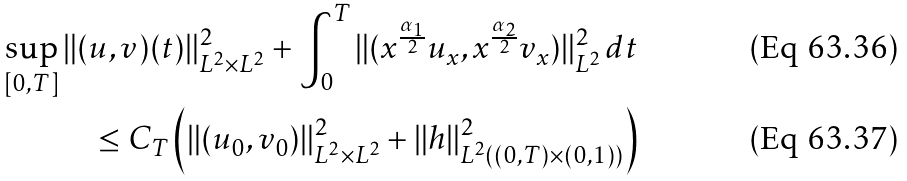Convert formula to latex. <formula><loc_0><loc_0><loc_500><loc_500>\sup _ { [ 0 , T ] } \| ( u , v ) ( t ) \| ^ { 2 } _ { L ^ { 2 } \times L ^ { 2 } } + \int _ { 0 } ^ { T } \| ( x ^ { \frac { \alpha _ { 1 } } { 2 } } u _ { x } , x ^ { \frac { \alpha _ { 2 } } { 2 } } v _ { x } ) \| ^ { 2 } _ { L ^ { 2 } } \, d t \\ \leq C _ { T } \left ( \| ( u _ { 0 } , v _ { 0 } ) \| ^ { 2 } _ { L ^ { 2 } \times L ^ { 2 } } + \| h \| ^ { 2 } _ { L ^ { 2 } ( ( 0 , T ) \times ( 0 , 1 ) ) } \right )</formula> 